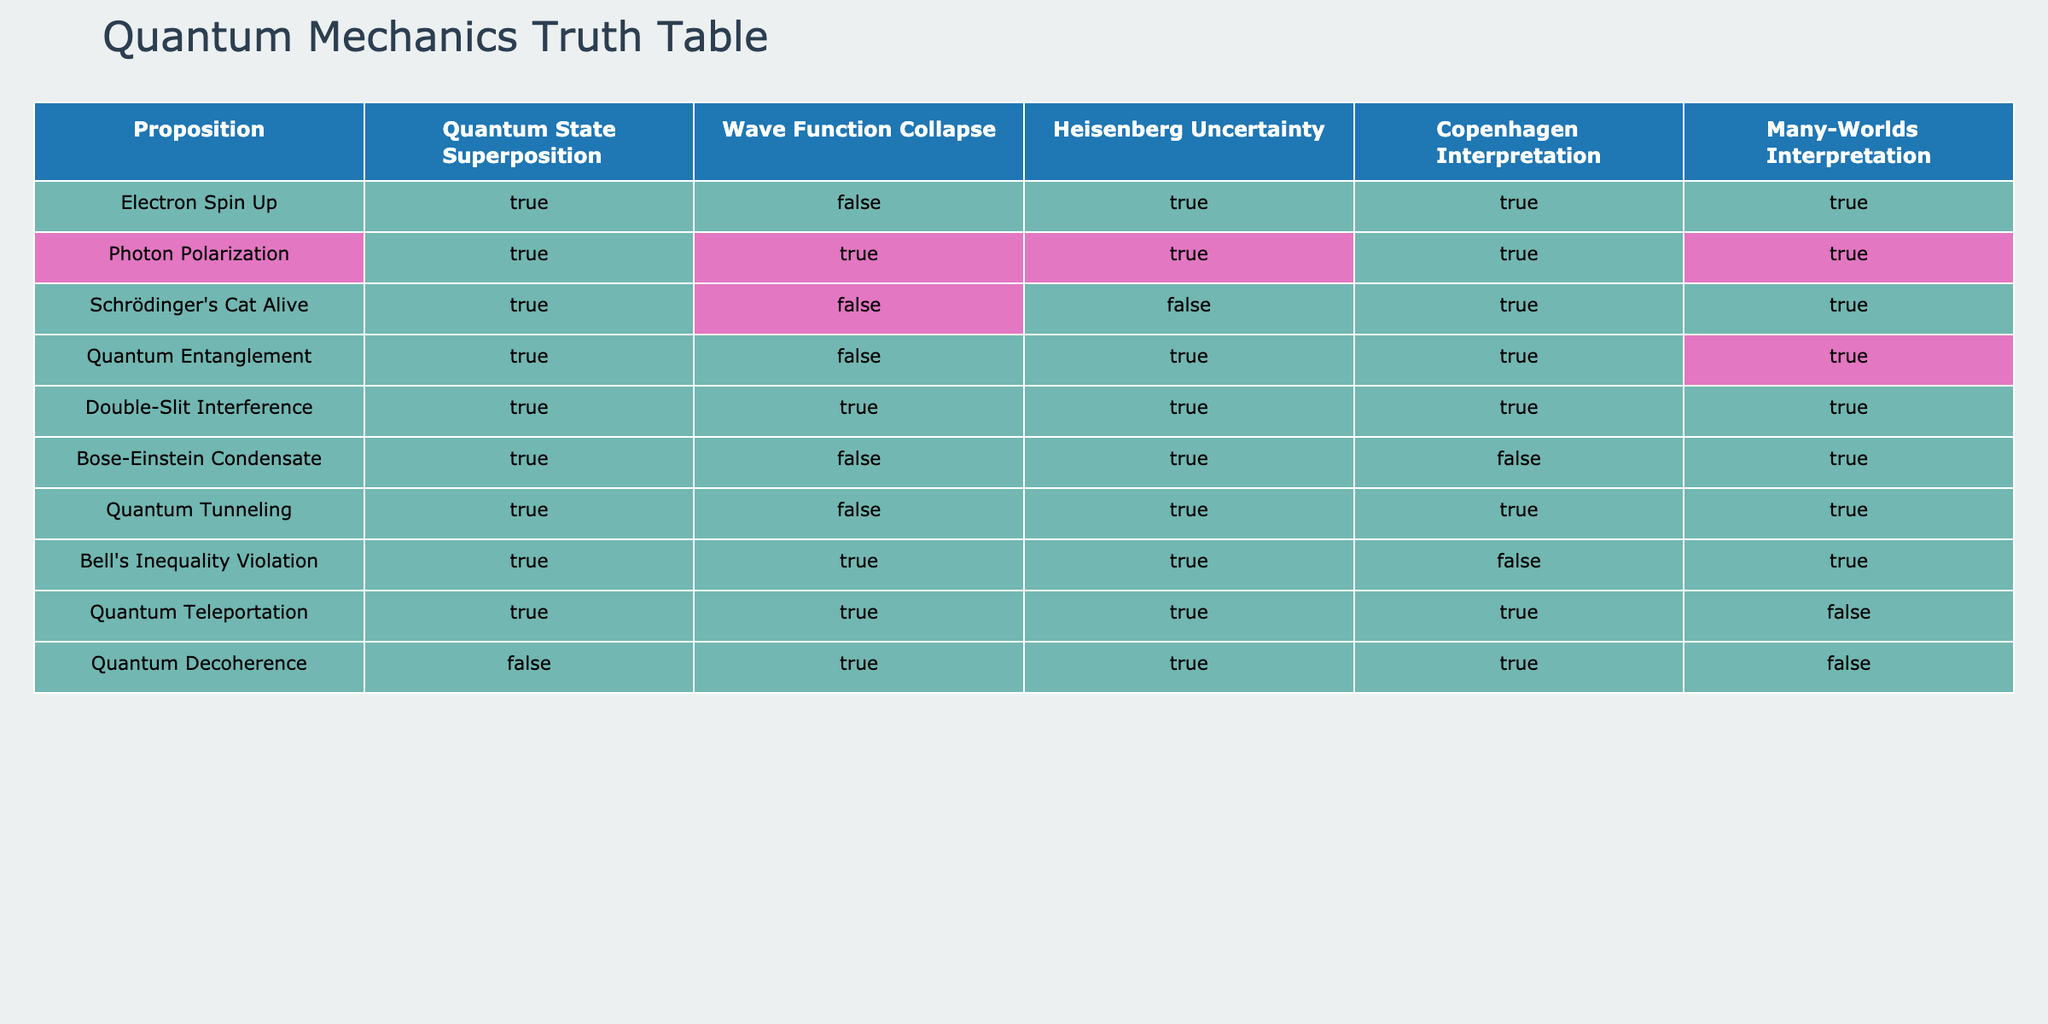What logical propositions have a True value under the Wave Function Collapse? In the table, I will check the column for Wave Function Collapse and identify the propositions marked as TRUE. They are: Photon Polarization, Double-Slit Interference, and Quantum Decoherence.
Answer: Photon Polarization, Double-Slit Interference Which propositions are associated with both the Copenhagen Interpretation and the Many-Worlds Interpretation? I need to look for the rows where both the Copenhagen Interpretation and Many-Worlds Interpretation columns are TRUE. The matching propositions are: Electron Spin Up, Photon Polarization, Schrödinger's Cat Alive, Quantum Entanglement, and Double-Slit Interference.
Answer: Electron Spin Up, Photon Polarization, Schrödinger's Cat Alive, Quantum Entanglement, Double-Slit Interference Are there any propositions where Quantum Decoherence is FALSE? I will check the Quantum Decoherence column for any instances of FALSE. The propositions with FALSE under Quantum Decoherence are: Schrödinger's Cat Alive, Quantum Tunneling, and Bose-Einstein Condensate.
Answer: Schrödinger's Cat Alive, Quantum Tunneling, Bose-Einstein Condensate What is the count of propositions that exhibit Quantum State Superposition as TRUE? I will count the number of TRUE entries in the Quantum State Superposition column. There are 9 propositions marked as TRUE in this column.
Answer: 9 Which proposition has Quantum Entanglement as TRUE and also Wave Function Collapse as FALSE? I will find rows where Quantum Entanglement is TRUE and Wave Function Collapse is FALSE. The only proposition that meets this criterion is Quantum Entanglement itself.
Answer: Quantum Entanglement 